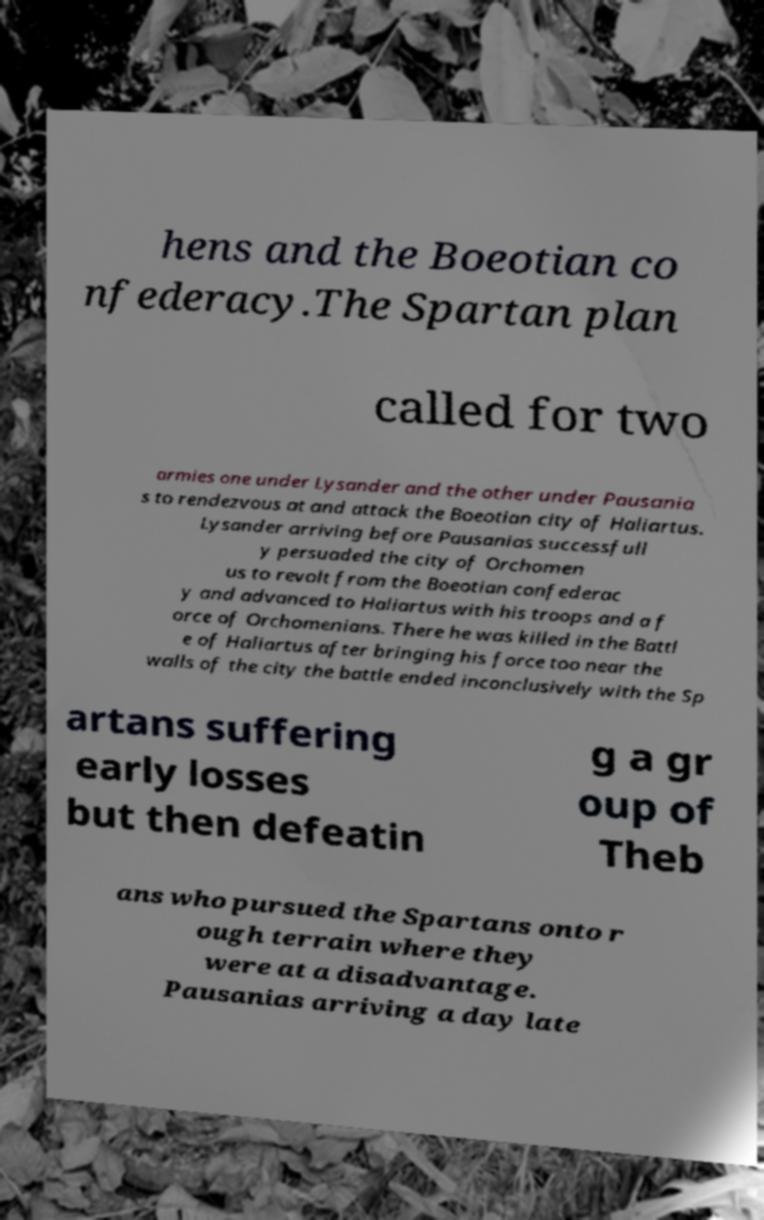Could you extract and type out the text from this image? hens and the Boeotian co nfederacy.The Spartan plan called for two armies one under Lysander and the other under Pausania s to rendezvous at and attack the Boeotian city of Haliartus. Lysander arriving before Pausanias successfull y persuaded the city of Orchomen us to revolt from the Boeotian confederac y and advanced to Haliartus with his troops and a f orce of Orchomenians. There he was killed in the Battl e of Haliartus after bringing his force too near the walls of the city the battle ended inconclusively with the Sp artans suffering early losses but then defeatin g a gr oup of Theb ans who pursued the Spartans onto r ough terrain where they were at a disadvantage. Pausanias arriving a day late 